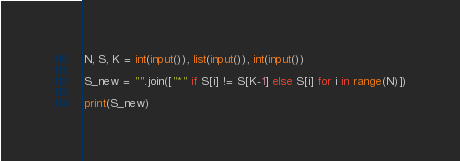<code> <loc_0><loc_0><loc_500><loc_500><_Python_>N, S, K = int(input()), list(input()), int(input())

S_new = "".join(["*" if S[i] != S[K-1] else S[i] for i in range(N)])

print(S_new)</code> 